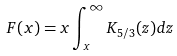Convert formula to latex. <formula><loc_0><loc_0><loc_500><loc_500>F ( x ) = x \int _ { x } ^ { \infty } K _ { 5 / 3 } ( z ) d z</formula> 